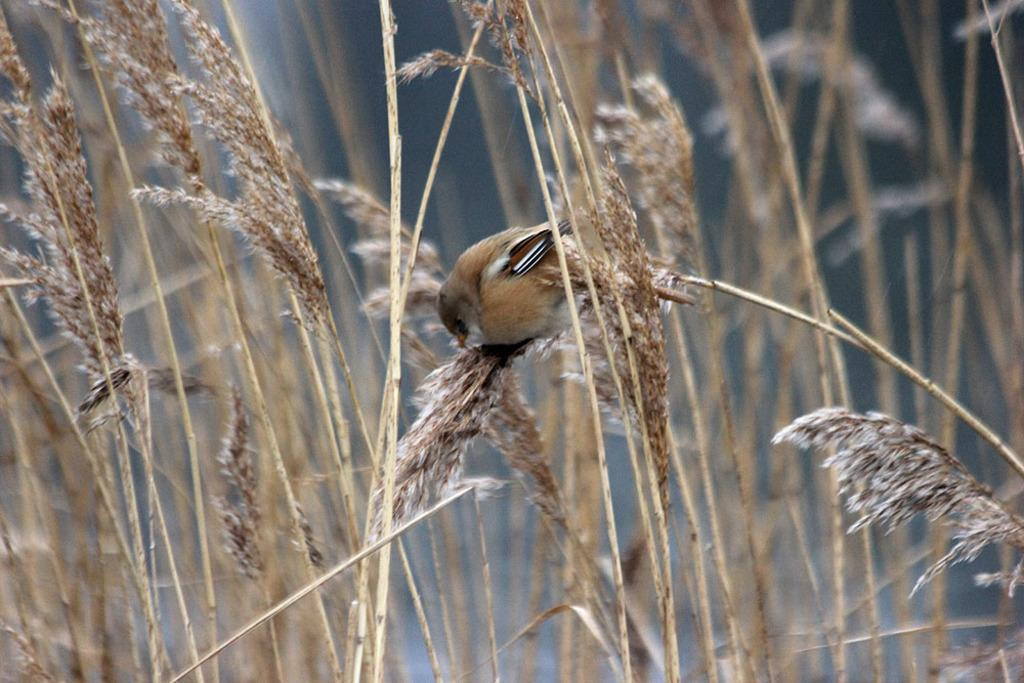What type of animal can be seen in the image? There is a bird in the image. What else is present in the image besides the bird? There are plants in the image. Can you describe the background of the image? The background of the image is blurry. What type of cream is being used to write on the plants in the image? There is no cream or writing present on the plants in the image. 